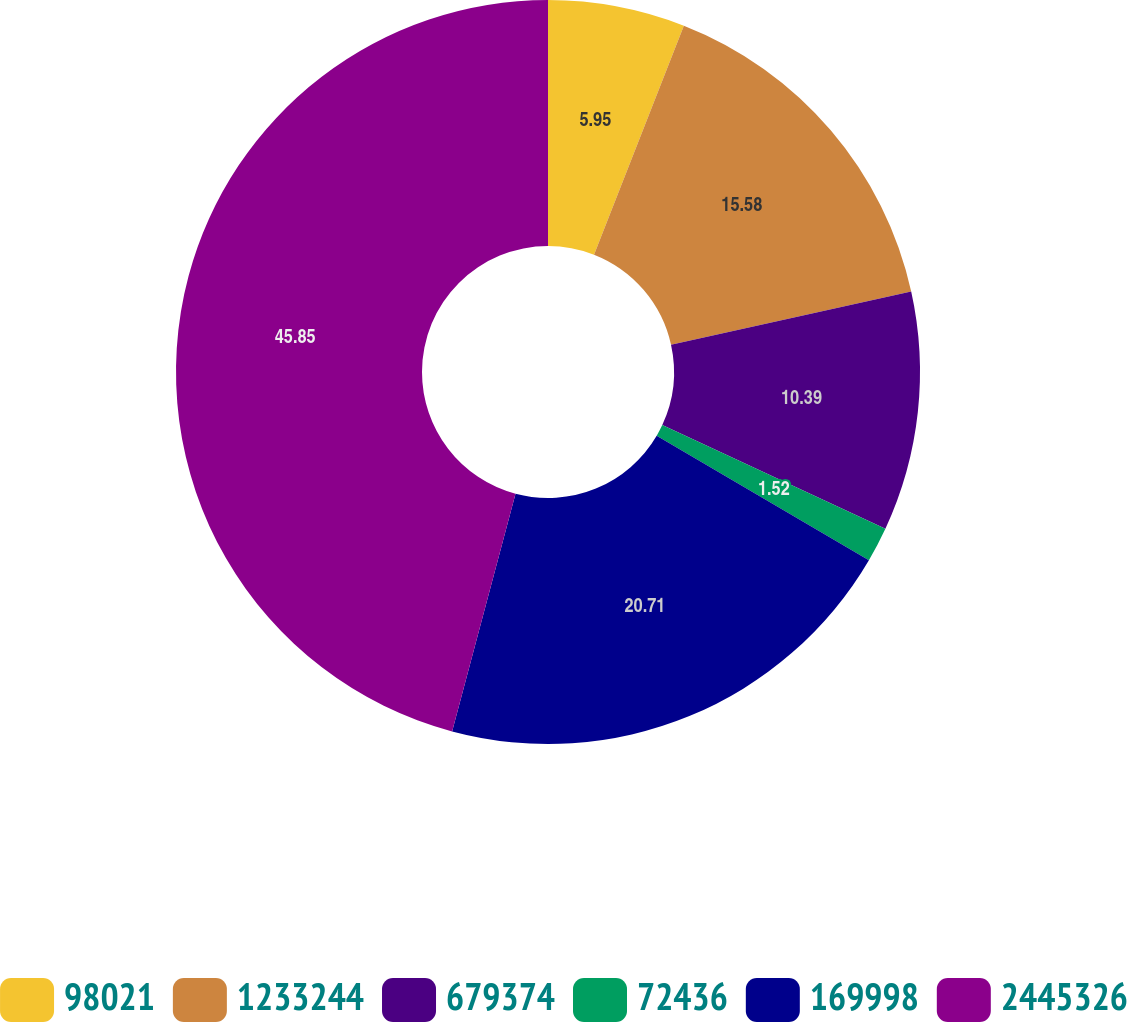<chart> <loc_0><loc_0><loc_500><loc_500><pie_chart><fcel>98021<fcel>1233244<fcel>679374<fcel>72436<fcel>169998<fcel>2445326<nl><fcel>5.95%<fcel>15.58%<fcel>10.39%<fcel>1.52%<fcel>20.71%<fcel>45.85%<nl></chart> 